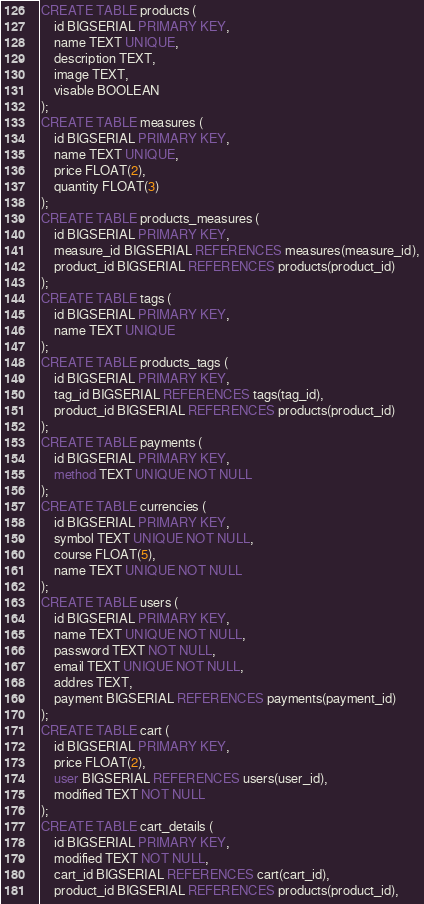<code> <loc_0><loc_0><loc_500><loc_500><_SQL_>CREATE TABLE products (
    id BIGSERIAL PRIMARY KEY,
    name TEXT UNIQUE,
    description TEXT,
    image TEXT,
    visable BOOLEAN
);
CREATE TABLE measures (
    id BIGSERIAL PRIMARY KEY,
    name TEXT UNIQUE,
    price FLOAT(2),
    quantity FLOAT(3)
);
CREATE TABLE products_measures (
    id BIGSERIAL PRIMARY KEY,
    measure_id BIGSERIAL REFERENCES measures(measure_id),
    product_id BIGSERIAL REFERENCES products(product_id)
);
CREATE TABLE tags (
    id BIGSERIAL PRIMARY KEY,
    name TEXT UNIQUE
);
CREATE TABLE products_tags (
    id BIGSERIAL PRIMARY KEY,
    tag_id BIGSERIAL REFERENCES tags(tag_id),
    product_id BIGSERIAL REFERENCES products(product_id)
);
CREATE TABLE payments (
    id BIGSERIAL PRIMARY KEY,
    method TEXT UNIQUE NOT NULL
);
CREATE TABLE currencies (
    id BIGSERIAL PRIMARY KEY,
    symbol TEXT UNIQUE NOT NULL,
    course FLOAT(5),
    name TEXT UNIQUE NOT NULL
);
CREATE TABLE users (
    id BIGSERIAL PRIMARY KEY,
    name TEXT UNIQUE NOT NULL,
    password TEXT NOT NULL,
    email TEXT UNIQUE NOT NULL, 
    addres TEXT,
    payment BIGSERIAL REFERENCES payments(payment_id)
);
CREATE TABLE cart (
    id BIGSERIAL PRIMARY KEY,
    price FLOAT(2),
    user BIGSERIAL REFERENCES users(user_id),
    modified TEXT NOT NULL
);
CREATE TABLE cart_details (
    id BIGSERIAL PRIMARY KEY,
    modified TEXT NOT NULL,
    cart_id BIGSERIAL REFERENCES cart(cart_id),
    product_id BIGSERIAL REFERENCES products(product_id),</code> 